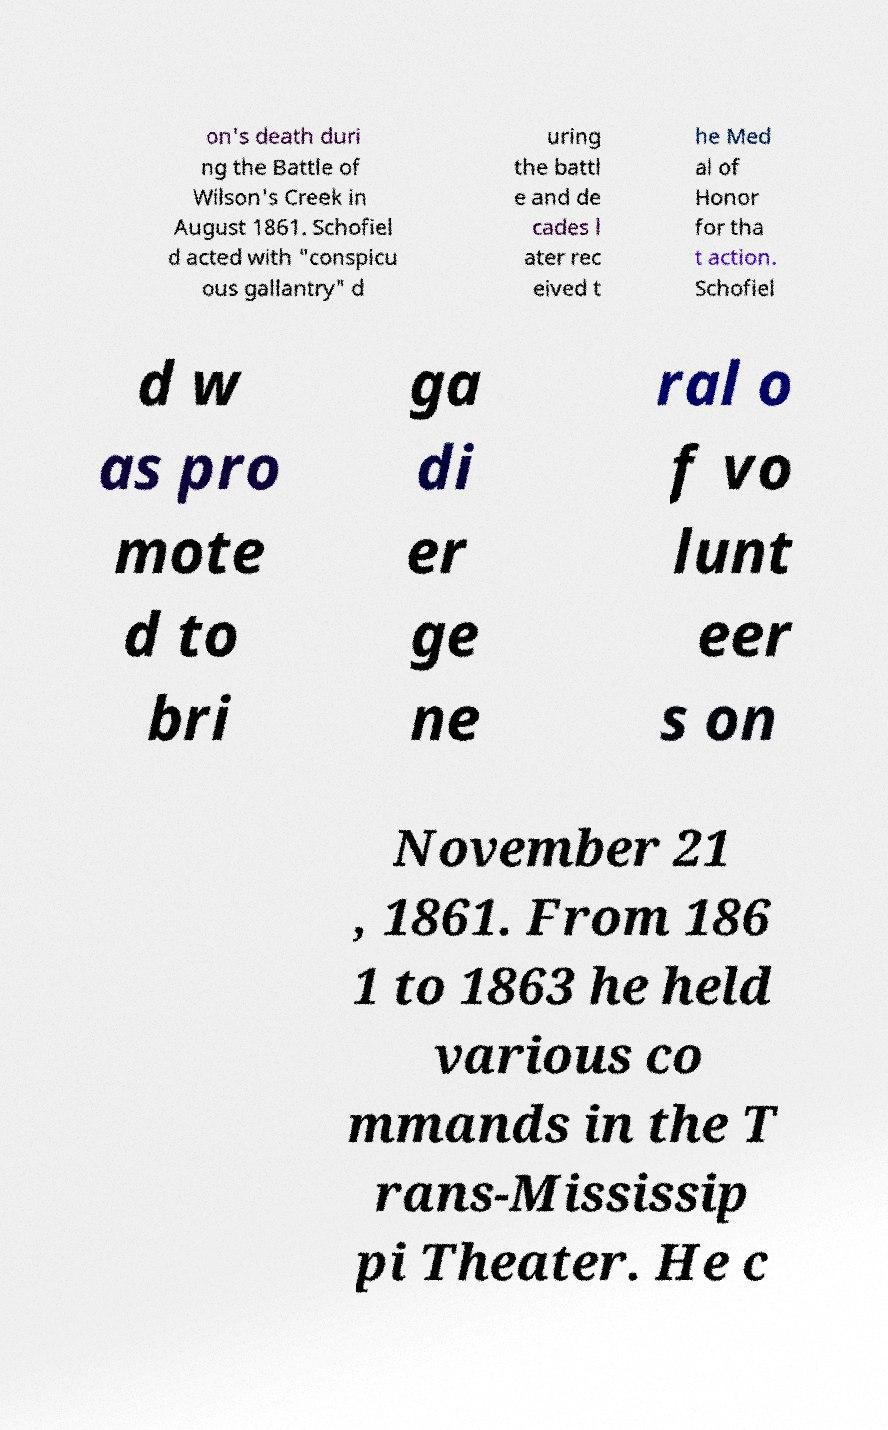Please identify and transcribe the text found in this image. on's death duri ng the Battle of Wilson's Creek in August 1861. Schofiel d acted with "conspicu ous gallantry" d uring the battl e and de cades l ater rec eived t he Med al of Honor for tha t action. Schofiel d w as pro mote d to bri ga di er ge ne ral o f vo lunt eer s on November 21 , 1861. From 186 1 to 1863 he held various co mmands in the T rans-Mississip pi Theater. He c 